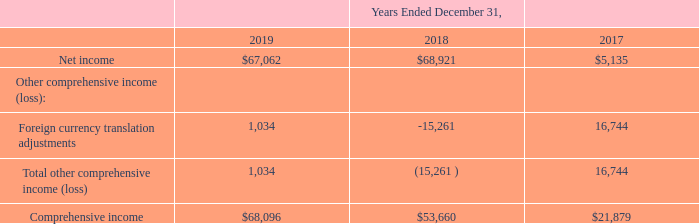ACI WORLDWIDE, INC. AND SUBSIDIARIES CONSOLIDATED STATEMENTS OF COMPREHENSIVE INCOME (in thousands)
The accompanying notes are an integral part of the consolidated financial statements.
What was the net income in 2019?
Answer scale should be: thousand. $67,062. What was the net income in 2017?
Answer scale should be: thousand. $5,135. What was the foreign currency translation adjustments in 2018?
Answer scale should be: thousand. -15,261. What was the change in net income between 2018 and 2019?
Answer scale should be: thousand. $67,062-$68,921
Answer: -1859. What was the change in comprehensive income between 2018 and 2019?
Answer scale should be: thousand. $68,096-$53,660
Answer: 14436. What was the percentage change in comprehensive income between 2017 and 2018?
Answer scale should be: percent. ($53,660-$21,879)/$21,879
Answer: 145.26. 